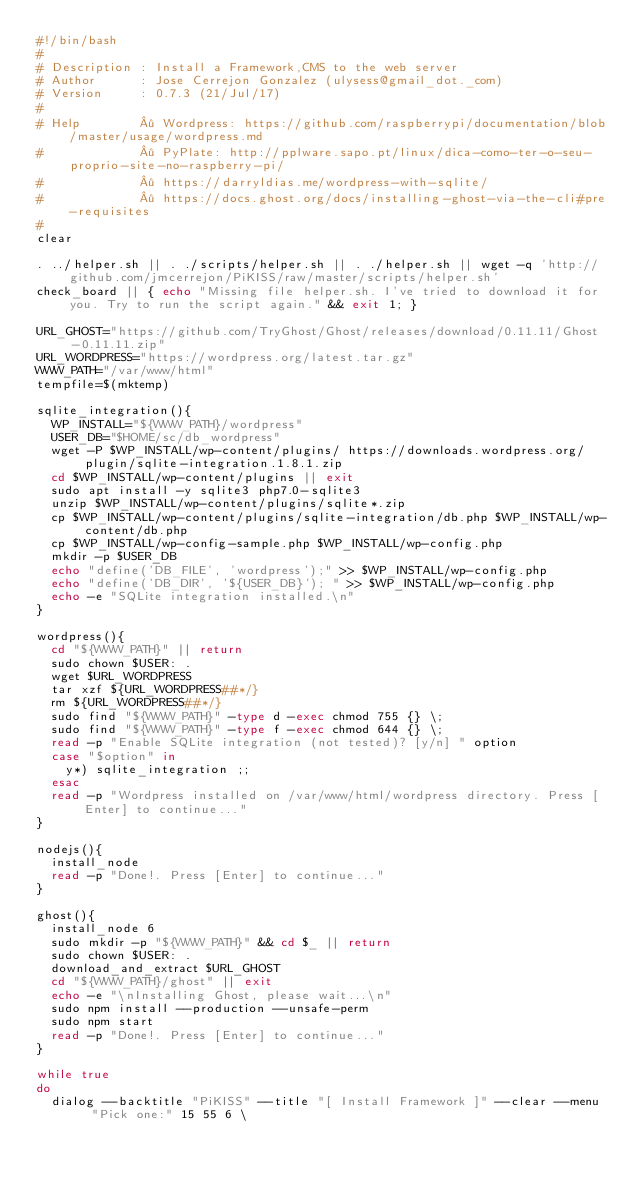<code> <loc_0><loc_0><loc_500><loc_500><_Bash_>#!/bin/bash
#
# Description : Install a Framework,CMS to the web server
# Author      : Jose Cerrejon Gonzalez (ulysess@gmail_dot._com)
# Version     : 0.7.3 (21/Jul/17)
#
# Help        · Wordpress: https://github.com/raspberrypi/documentation/blob/master/usage/wordpress.md
#             · PyPlate: http://pplware.sapo.pt/linux/dica-como-ter-o-seu-proprio-site-no-raspberry-pi/
#             · https://darryldias.me/wordpress-with-sqlite/
#             · https://docs.ghost.org/docs/installing-ghost-via-the-cli#pre-requisites
#
clear

. ../helper.sh || . ./scripts/helper.sh || . ./helper.sh || wget -q 'http://github.com/jmcerrejon/PiKISS/raw/master/scripts/helper.sh'
check_board || { echo "Missing file helper.sh. I've tried to download it for you. Try to run the script again." && exit 1; }

URL_GHOST="https://github.com/TryGhost/Ghost/releases/download/0.11.11/Ghost-0.11.11.zip"
URL_WORDPRESS="https://wordpress.org/latest.tar.gz"
WWW_PATH="/var/www/html"
tempfile=$(mktemp)

sqlite_integration(){
  WP_INSTALL="${WWW_PATH}/wordpress"
  USER_DB="$HOME/sc/db_wordpress"
  wget -P $WP_INSTALL/wp-content/plugins/ https://downloads.wordpress.org/plugin/sqlite-integration.1.8.1.zip
  cd $WP_INSTALL/wp-content/plugins || exit
  sudo apt install -y sqlite3 php7.0-sqlite3
  unzip $WP_INSTALL/wp-content/plugins/sqlite*.zip
  cp $WP_INSTALL/wp-content/plugins/sqlite-integration/db.php $WP_INSTALL/wp-content/db.php
  cp $WP_INSTALL/wp-config-sample.php $WP_INSTALL/wp-config.php
  mkdir -p $USER_DB
  echo "define('DB_FILE', 'wordpress');" >> $WP_INSTALL/wp-config.php
  echo "define('DB_DIR', '${USER_DB}'); " >> $WP_INSTALL/wp-config.php
  echo -e "SQLite integration installed.\n"
}

wordpress(){
  cd "${WWW_PATH}" || return
  sudo chown $USER: .
  wget $URL_WORDPRESS
  tar xzf ${URL_WORDPRESS##*/}
  rm ${URL_WORDPRESS##*/}
  sudo find "${WWW_PATH}" -type d -exec chmod 755 {} \;
  sudo find "${WWW_PATH}" -type f -exec chmod 644 {} \;
  read -p "Enable SQLite integration (not tested)? [y/n] " option
  case "$option" in
    y*) sqlite_integration ;;
  esac
  read -p "Wordpress installed on /var/www/html/wordpress directory. Press [Enter] to continue..."
}

nodejs(){
  install_node
  read -p "Done!. Press [Enter] to continue..."
}

ghost(){
  install_node 6
  sudo mkdir -p "${WWW_PATH}" && cd $_ || return
  sudo chown $USER: .
  download_and_extract $URL_GHOST
  cd "${WWW_PATH}/ghost" || exit
  echo -e "\nInstalling Ghost, please wait...\n"
  sudo npm install --production --unsafe-perm
  sudo npm start
  read -p "Done!. Press [Enter] to continue..."
}

while true
do
  dialog --backtitle "PiKISS" --title "[ Install Framework ]" --clear --menu  "Pick one:" 15 55 6 \</code> 